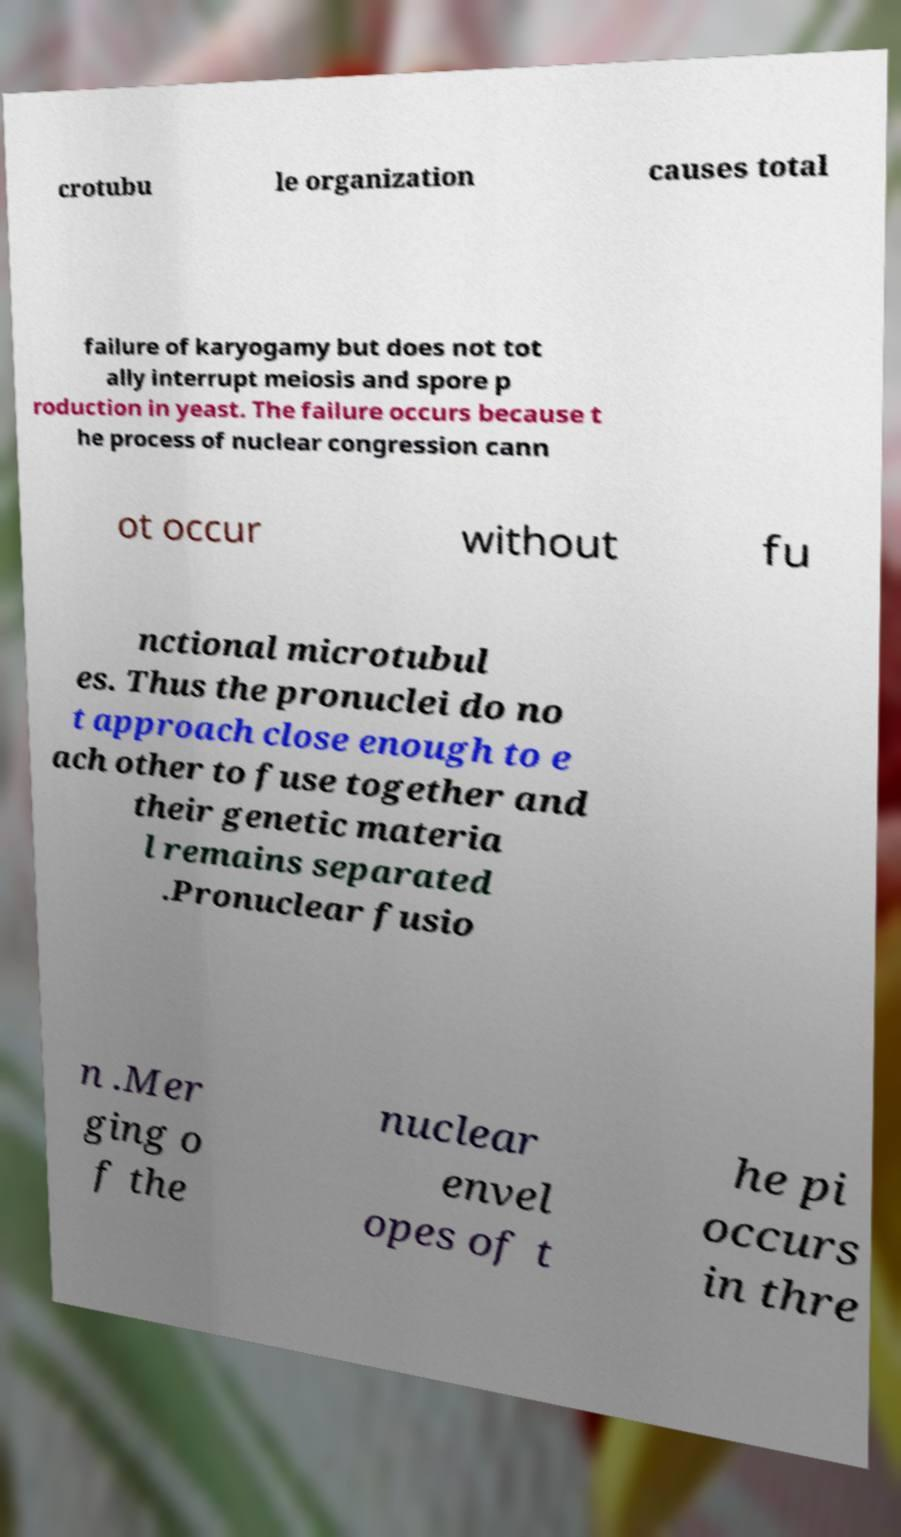There's text embedded in this image that I need extracted. Can you transcribe it verbatim? crotubu le organization causes total failure of karyogamy but does not tot ally interrupt meiosis and spore p roduction in yeast. The failure occurs because t he process of nuclear congression cann ot occur without fu nctional microtubul es. Thus the pronuclei do no t approach close enough to e ach other to fuse together and their genetic materia l remains separated .Pronuclear fusio n .Mer ging o f the nuclear envel opes of t he pi occurs in thre 